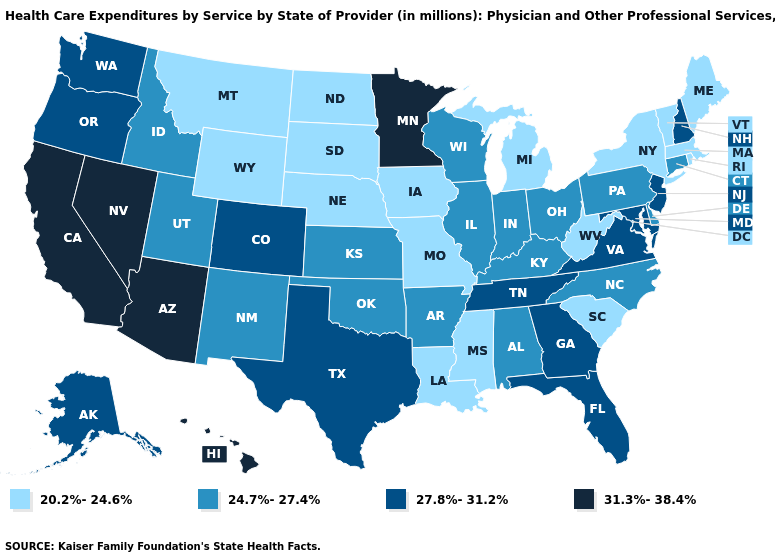What is the value of Oklahoma?
Quick response, please. 24.7%-27.4%. What is the value of Arizona?
Short answer required. 31.3%-38.4%. Does Oregon have the same value as Colorado?
Give a very brief answer. Yes. Does Connecticut have the same value as Maine?
Short answer required. No. Does the map have missing data?
Give a very brief answer. No. What is the lowest value in the USA?
Quick response, please. 20.2%-24.6%. What is the lowest value in the Northeast?
Keep it brief. 20.2%-24.6%. What is the value of Utah?
Give a very brief answer. 24.7%-27.4%. Name the states that have a value in the range 27.8%-31.2%?
Concise answer only. Alaska, Colorado, Florida, Georgia, Maryland, New Hampshire, New Jersey, Oregon, Tennessee, Texas, Virginia, Washington. Name the states that have a value in the range 27.8%-31.2%?
Answer briefly. Alaska, Colorado, Florida, Georgia, Maryland, New Hampshire, New Jersey, Oregon, Tennessee, Texas, Virginia, Washington. Name the states that have a value in the range 31.3%-38.4%?
Write a very short answer. Arizona, California, Hawaii, Minnesota, Nevada. What is the lowest value in the USA?
Concise answer only. 20.2%-24.6%. Name the states that have a value in the range 24.7%-27.4%?
Be succinct. Alabama, Arkansas, Connecticut, Delaware, Idaho, Illinois, Indiana, Kansas, Kentucky, New Mexico, North Carolina, Ohio, Oklahoma, Pennsylvania, Utah, Wisconsin. Among the states that border Utah , does Wyoming have the lowest value?
Concise answer only. Yes. What is the value of Kansas?
Be succinct. 24.7%-27.4%. 